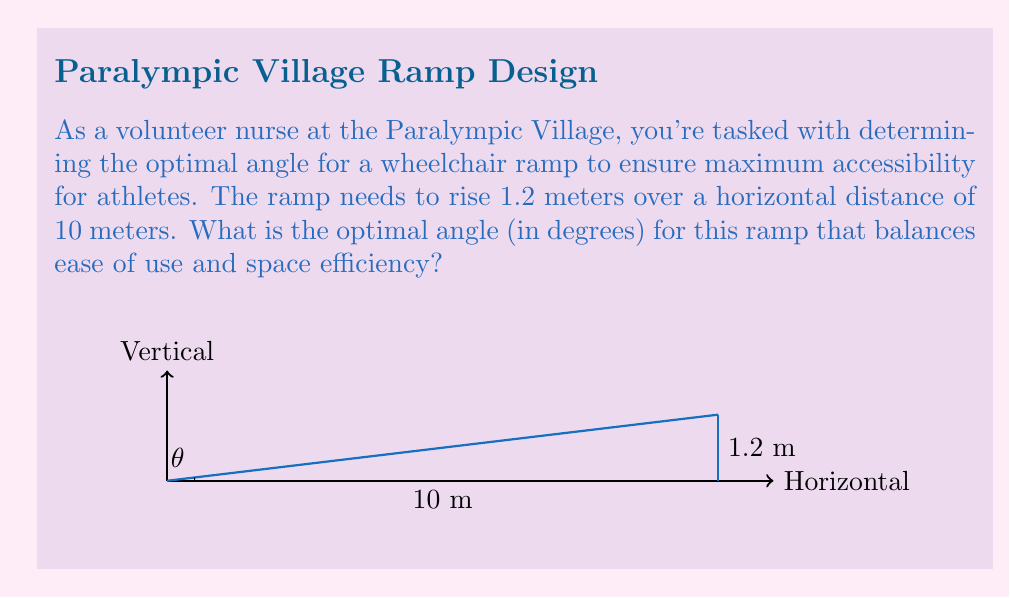Could you help me with this problem? To solve this problem, we'll follow these steps:

1) First, we need to calculate the angle of the ramp using the given dimensions. We can use the arctangent function for this.

2) The angle $\theta$ is given by:

   $$\theta = \arctan(\frac{\text{rise}}{\text{run}})$$

3) Substituting our values:

   $$\theta = \arctan(\frac{1.2}{10})$$

4) Calculate this value:

   $$\theta = \arctan(0.12) \approx 6.84^\circ$$

5) Now, we need to consider the optimal angle for wheelchair ramps. According to accessibility standards, the maximum recommended slope for a wheelchair ramp is 1:12, which corresponds to an angle of about 4.76°. However, this is a maximum, and a slightly gentler slope is often preferred for easier access.

6) Given that our calculated angle (6.84°) is steeper than the recommended maximum, we should adjust it to the standard 1:12 ratio.

7) The optimal angle can be calculated as:

   $$\theta_{\text{optimal}} = \arctan(\frac{1}{12}) \approx 4.76^\circ$$

This angle provides a good balance between accessibility and space efficiency.
Answer: $4.76^\circ$ 